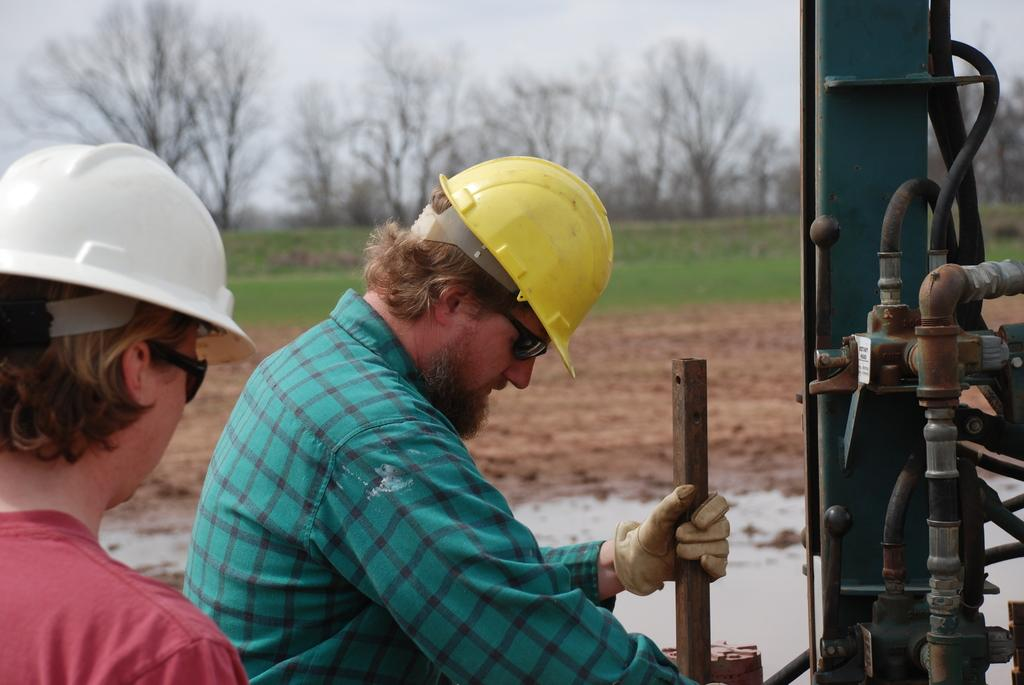How many persons are in the image? There are persons standing in the image. What are the persons wearing on their heads? The persons are wearing helmets. What are the persons holding in the image? The persons are holding an object. What can be seen in the background of the image? There are trees, grass, sand, and the sky visible in the background of the image. What is the daughter's name in the image? There is no mention of a daughter or any names in the image. What activity are the persons participating in during recess? The image does not depict a recess or any specific activity; it simply shows persons standing with helmets and holding an object. 